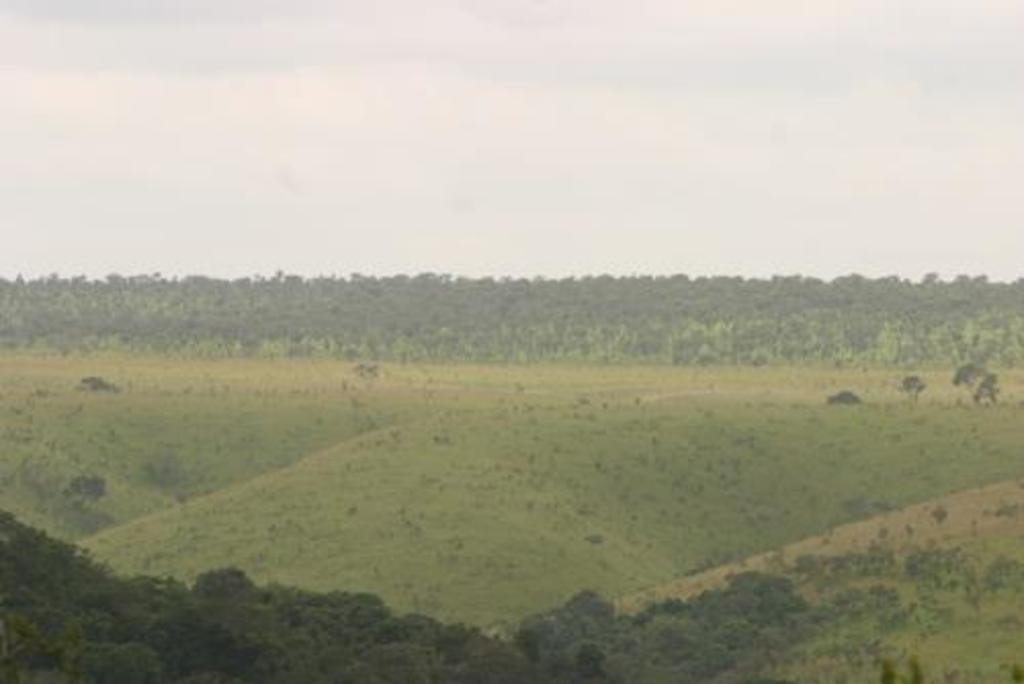What type of environment is depicted in the image? The image is an outside view. What type of vegetation can be seen in the image? There are many trees in the image. What type of ground cover is visible in the image? There is grass visible in the image? What is visible at the top of the image? The sky is visible at the top of the image. Can you see any quicksand in the image? No, there is no quicksand present in the image. How many rings are visible on the trees in the image? There are no rings visible on the trees in the image, as rings are not visible from the outside of a tree. 